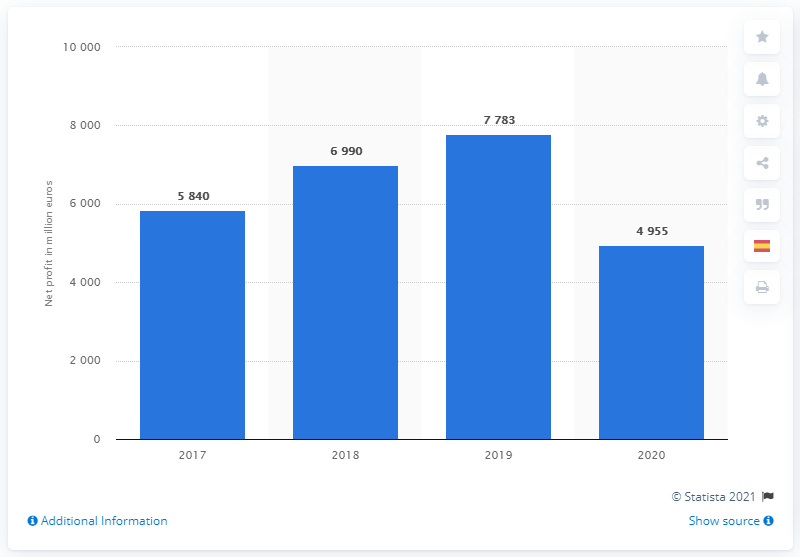Give some essential details in this illustration. LVMH reported a net profit of 495.5 million euros in 2020. 